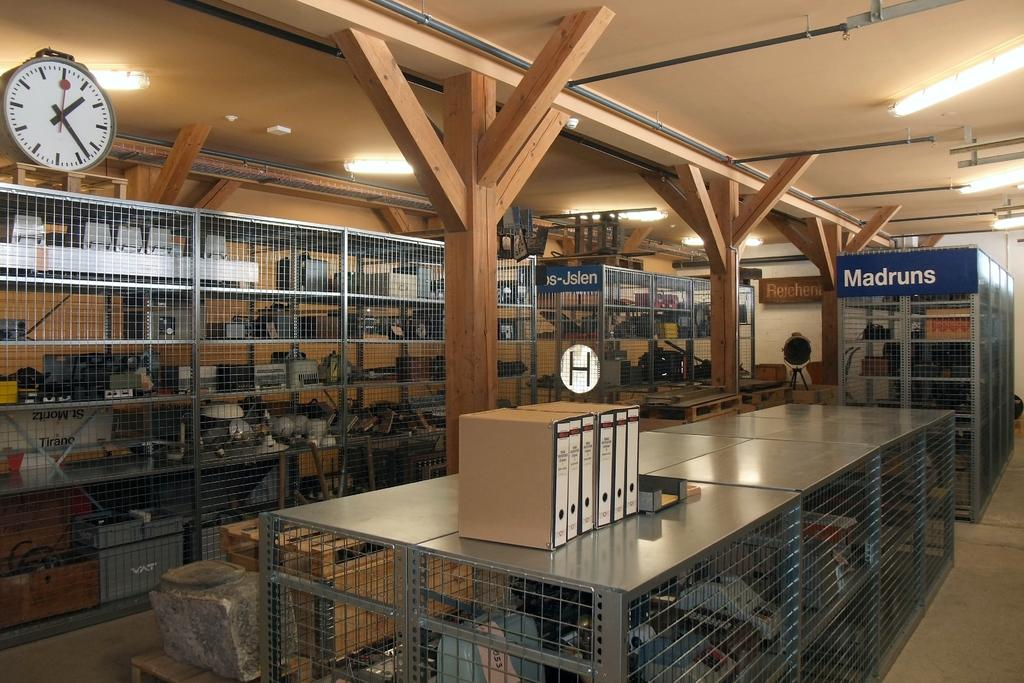Provide a one-sentence caption for the provided image. stacks of items on shelves behind bars with on labels madruns. 